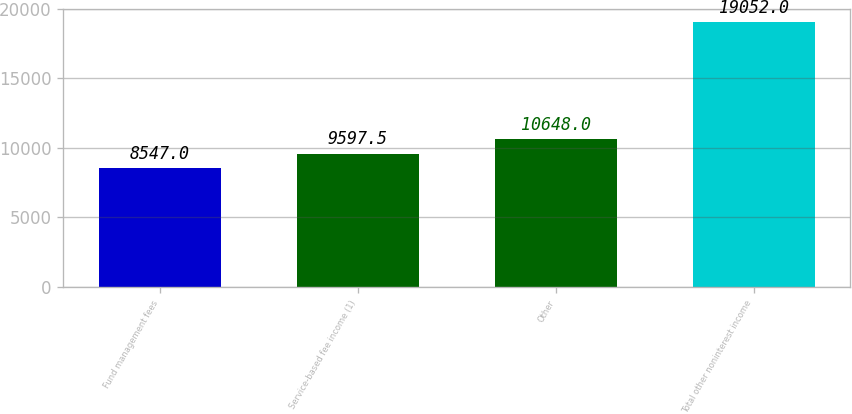<chart> <loc_0><loc_0><loc_500><loc_500><bar_chart><fcel>Fund management fees<fcel>Service-based fee income (1)<fcel>Other<fcel>Total other noninterest income<nl><fcel>8547<fcel>9597.5<fcel>10648<fcel>19052<nl></chart> 